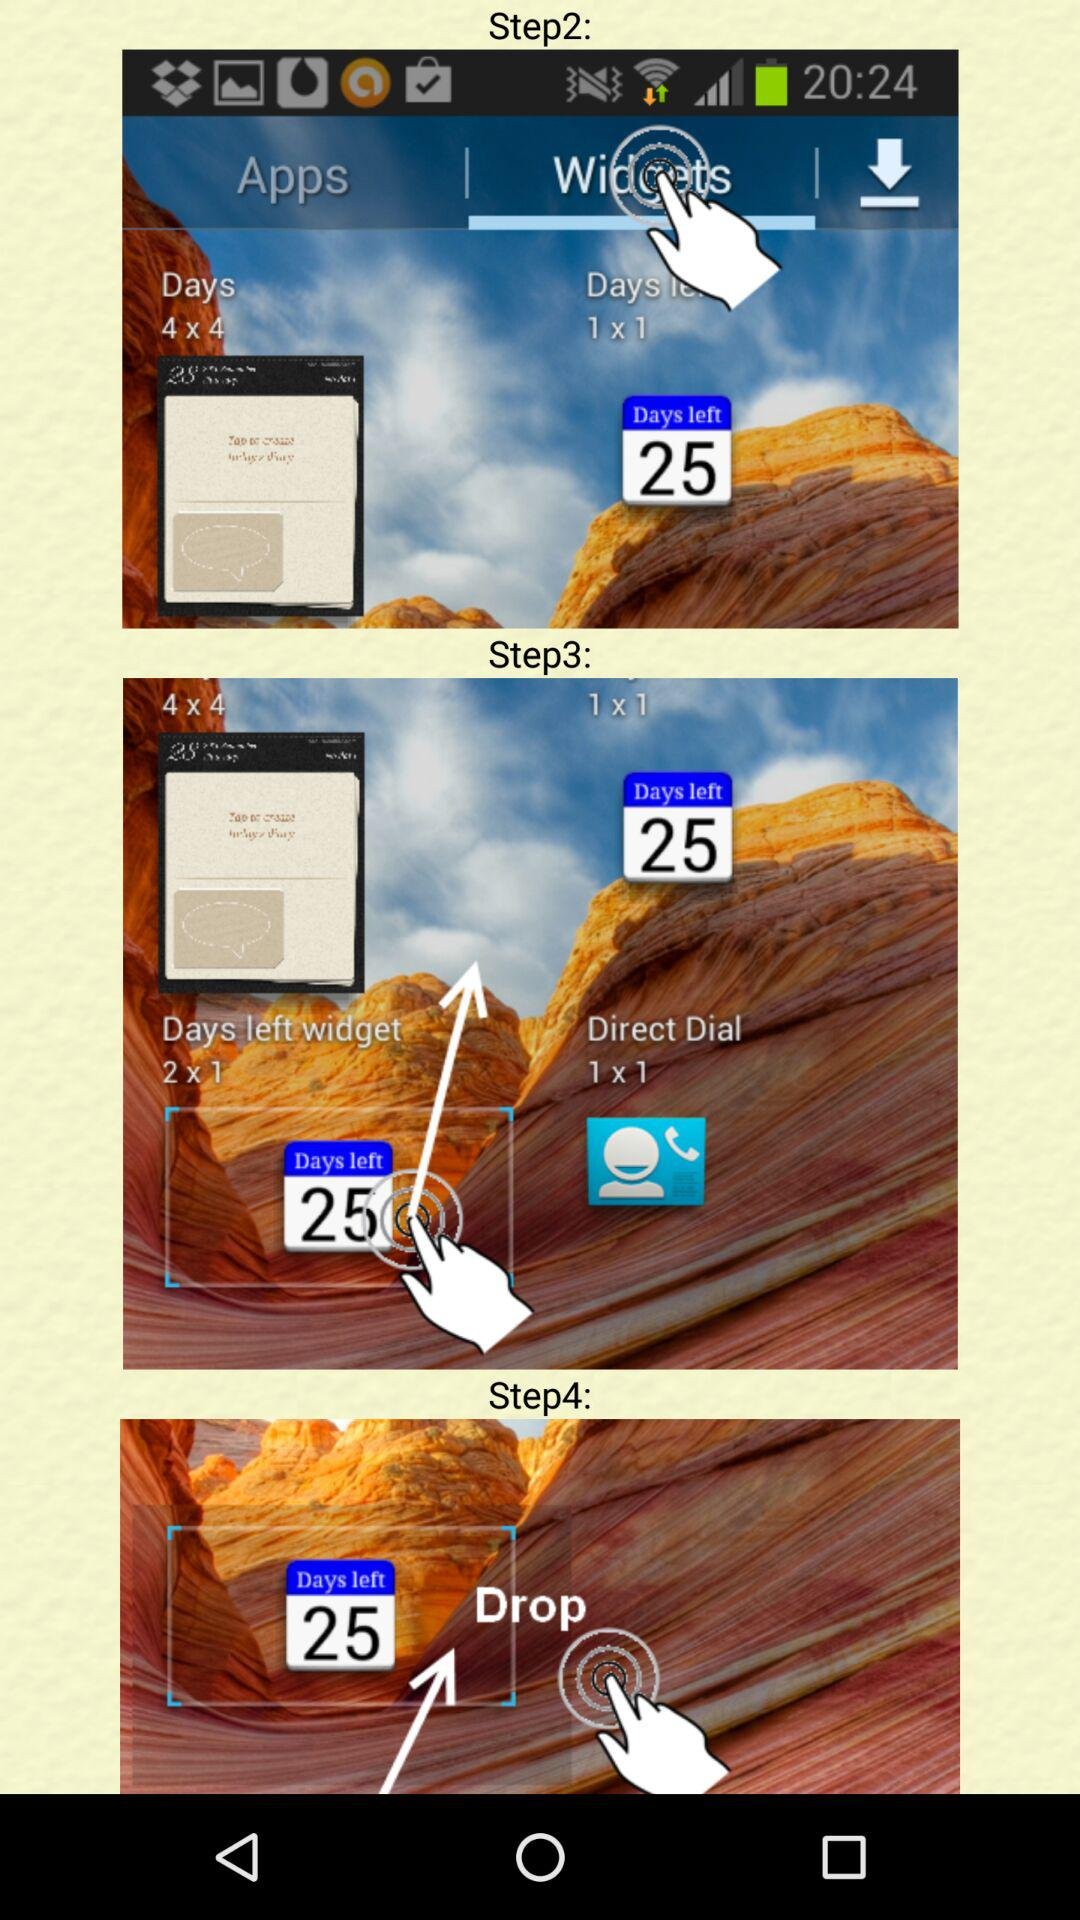How many days are left for the user to complete the task?
Answer the question using a single word or phrase. 25 